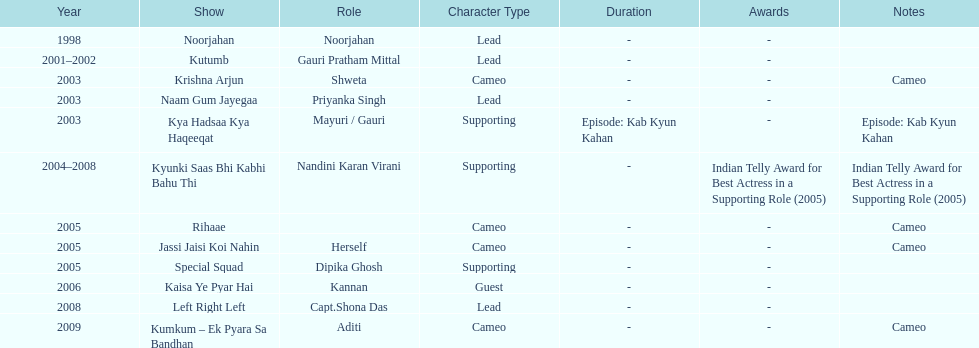Which was the only television show gauri starred in, in which she played herself? Jassi Jaisi Koi Nahin. 